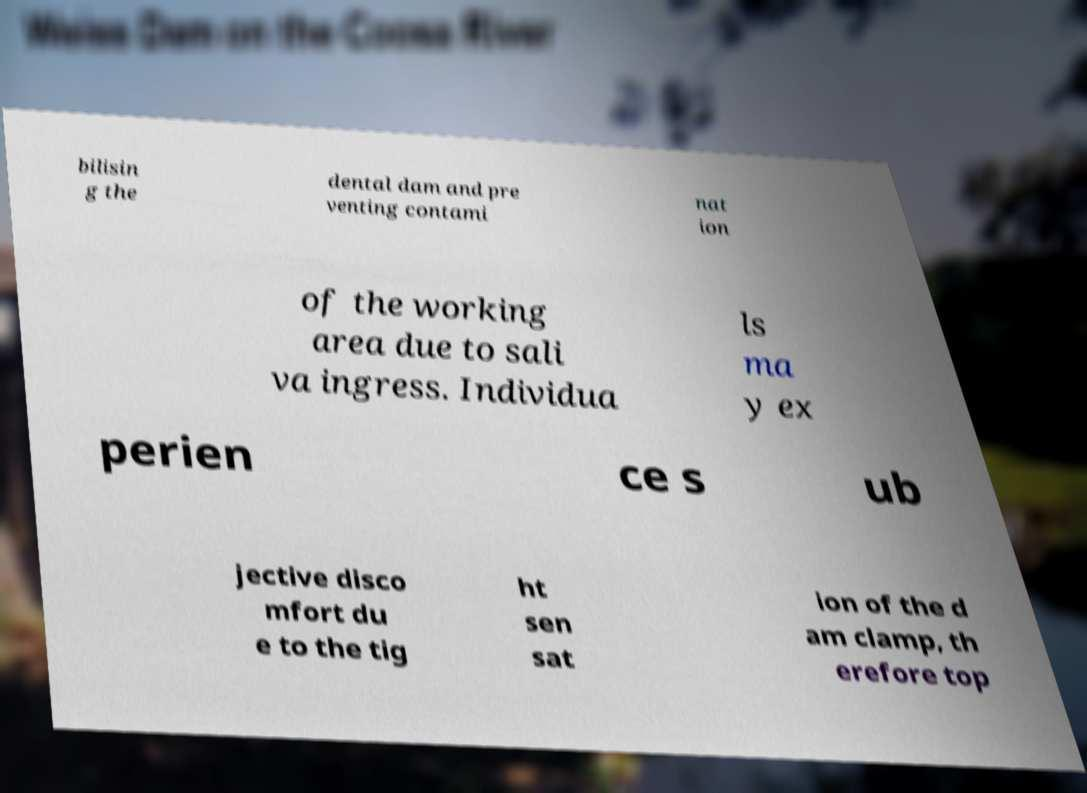What messages or text are displayed in this image? I need them in a readable, typed format. bilisin g the dental dam and pre venting contami nat ion of the working area due to sali va ingress. Individua ls ma y ex perien ce s ub jective disco mfort du e to the tig ht sen sat ion of the d am clamp, th erefore top 